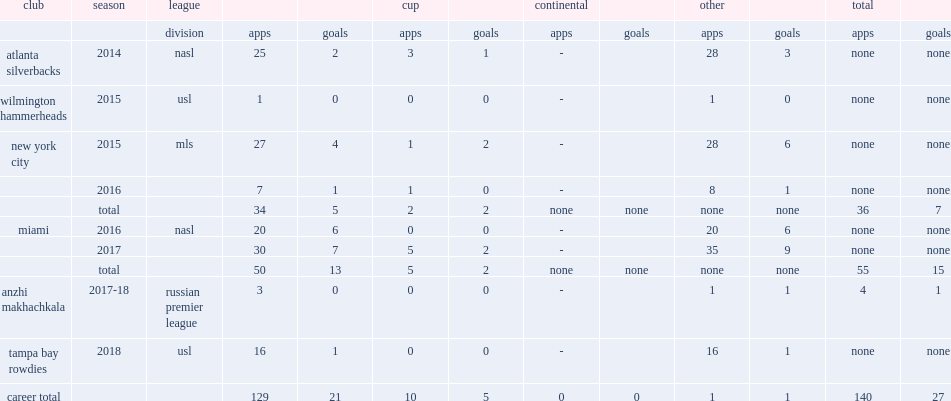Which club did poku play for in 2014? Atlanta silverbacks. Can you parse all the data within this table? {'header': ['club', 'season', 'league', '', '', 'cup', '', 'continental', '', 'other', '', 'total', ''], 'rows': [['', '', 'division', 'apps', 'goals', 'apps', 'goals', 'apps', 'goals', 'apps', 'goals', 'apps', 'goals'], ['atlanta silverbacks', '2014', 'nasl', '25', '2', '3', '1', '-', '', '28', '3', 'none', 'none'], ['wilmington hammerheads', '2015', 'usl', '1', '0', '0', '0', '-', '', '1', '0', 'none', 'none'], ['new york city', '2015', 'mls', '27', '4', '1', '2', '-', '', '28', '6', 'none', 'none'], ['', '2016', '', '7', '1', '1', '0', '-', '', '8', '1', 'none', 'none'], ['', 'total', '', '34', '5', '2', '2', 'none', 'none', 'none', 'none', '36', '7'], ['miami', '2016', 'nasl', '20', '6', '0', '0', '-', '', '20', '6', 'none', 'none'], ['', '2017', '', '30', '7', '5', '2', '-', '', '35', '9', 'none', 'none'], ['', 'total', '', '50', '13', '5', '2', 'none', 'none', 'none', 'none', '55', '15'], ['anzhi makhachkala', '2017-18', 'russian premier league', '3', '0', '0', '0', '-', '', '1', '1', '4', '1'], ['tampa bay rowdies', '2018', 'usl', '16', '1', '0', '0', '-', '', '16', '1', 'none', 'none'], ['career total', '', '', '129', '21', '10', '5', '0', '0', '1', '1', '140', '27']]} 